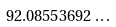Convert formula to latex. <formula><loc_0><loc_0><loc_500><loc_500>9 2 . 0 8 5 5 3 6 9 2 \dots \</formula> 